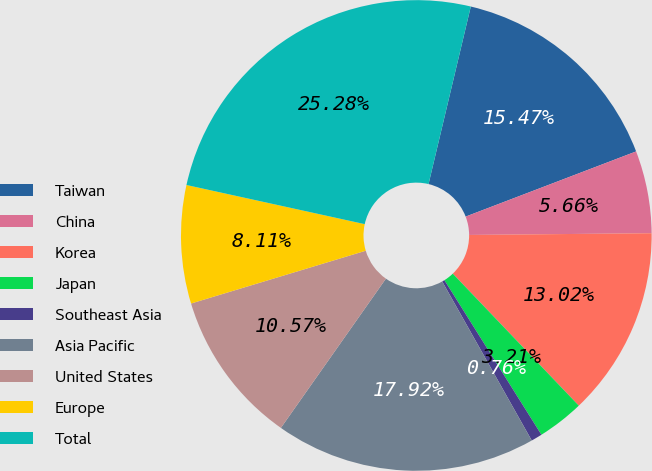Convert chart. <chart><loc_0><loc_0><loc_500><loc_500><pie_chart><fcel>Taiwan<fcel>China<fcel>Korea<fcel>Japan<fcel>Southeast Asia<fcel>Asia Pacific<fcel>United States<fcel>Europe<fcel>Total<nl><fcel>15.47%<fcel>5.66%<fcel>13.02%<fcel>3.21%<fcel>0.76%<fcel>17.92%<fcel>10.57%<fcel>8.11%<fcel>25.28%<nl></chart> 